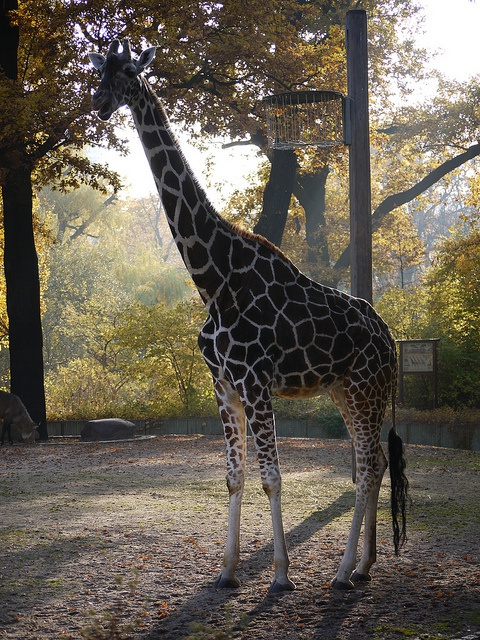Describe the objects in this image and their specific colors. I can see a giraffe in black and gray tones in this image. 